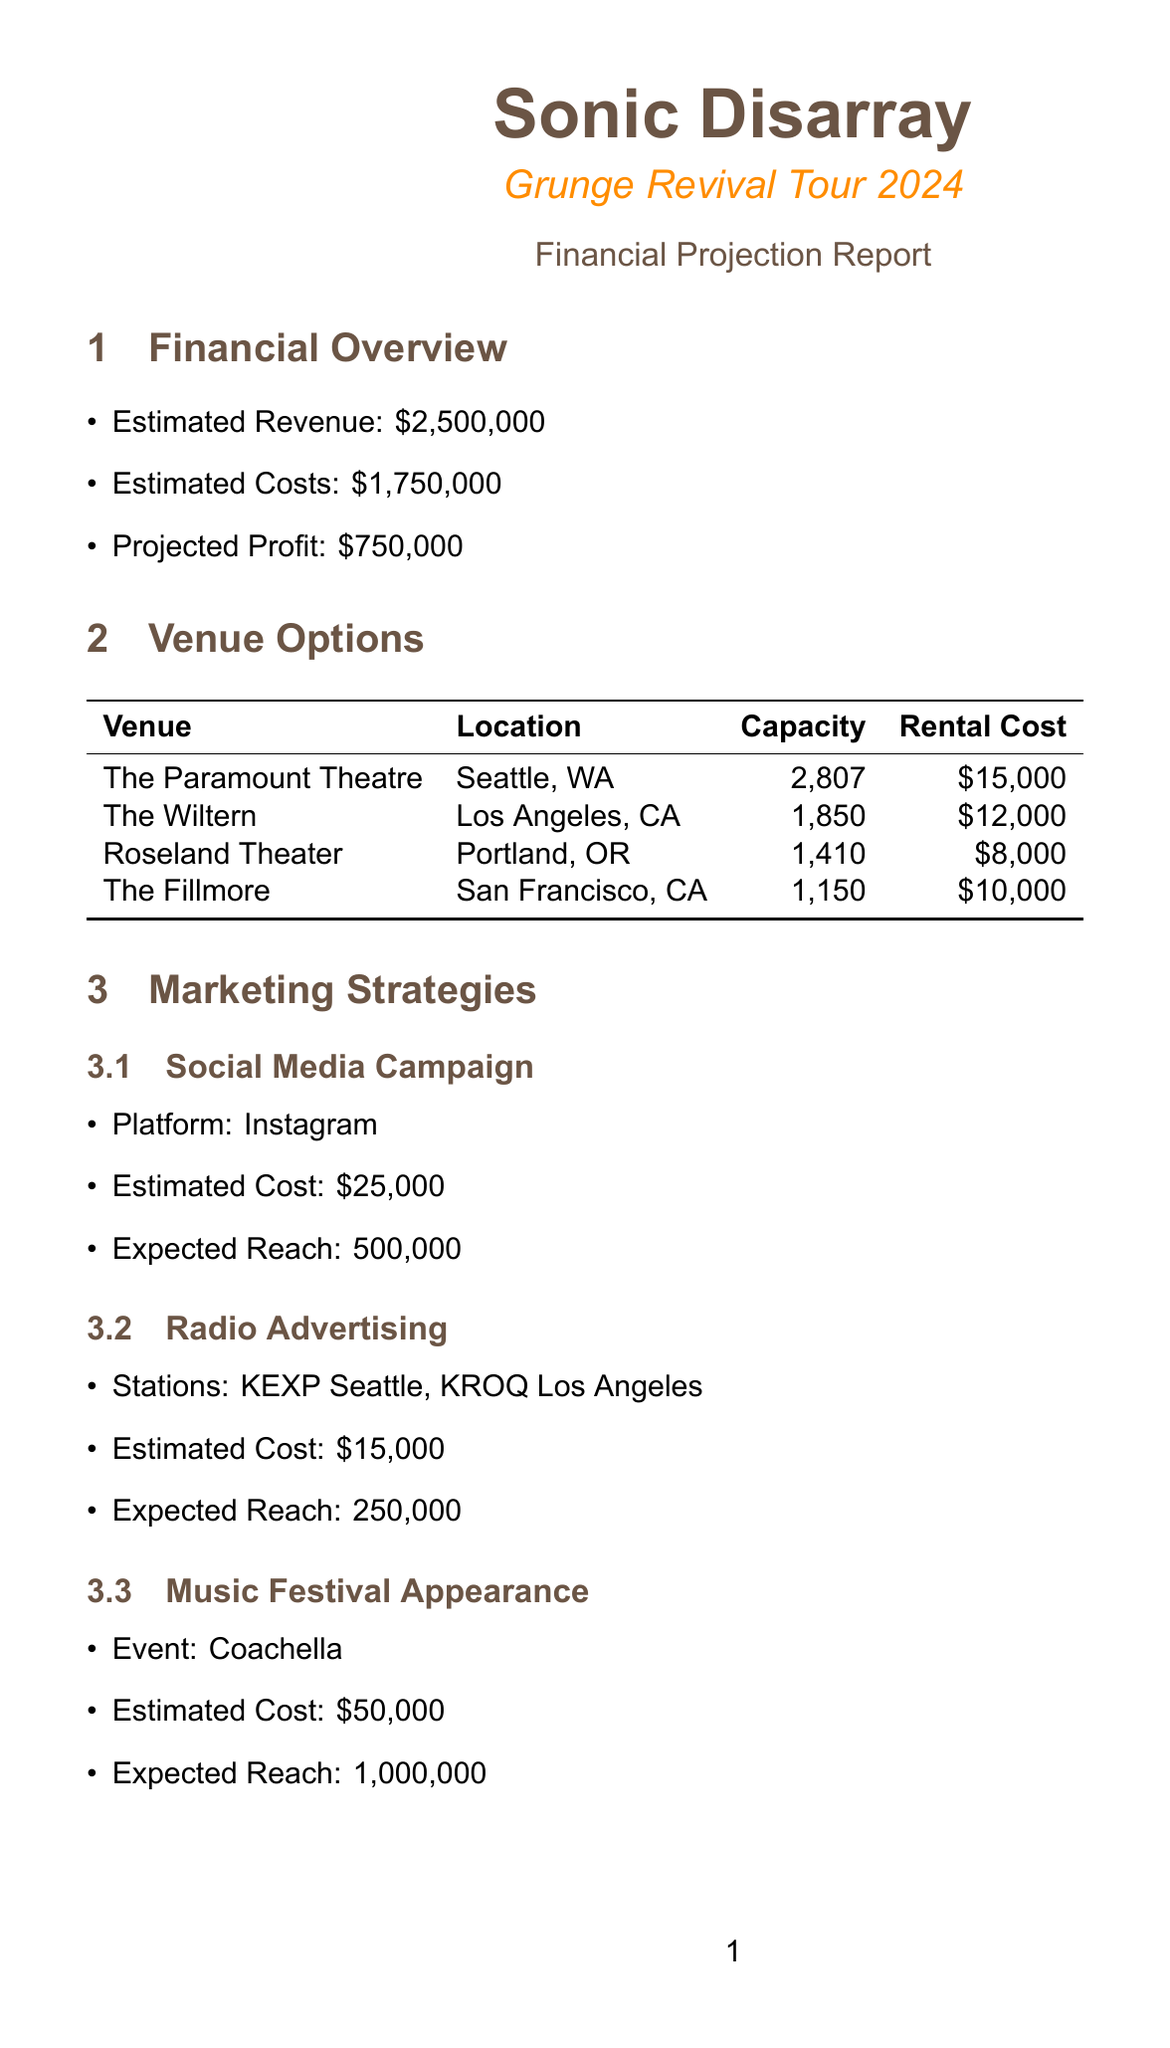what is the estimated revenue for the tour? The estimated revenue is explicitly mentioned in the financial overview section of the document.
Answer: $2,500,000 what is the name of the reunion tour? The name of the reunion tour is stated in the title of the document.
Answer: Grunge Revival Tour 2024 how much is the rental cost for The Fillmore? This rental cost is provided in the venue options table within the document.
Answer: $10,000 what is the expected reach of the Instagram campaign? The expected reach for the Instagram campaign is specified in the marketing strategies section.
Answer: 500,000 how much will be spent on sound equipment? The estimated cost for sound equipment is included in the production costs section.
Answer: $50,000 which venue has the highest capacity? The venue with the highest capacity can be found in the venue options table.
Answer: The Paramount Theatre what is the estimated profit from the reunion tour? The estimated profit is detailed in the financial overview section of the report.
Answer: $750,000 how many roadies will be funded at $150,000? The total salaries for roadies are provided, indicating how much will be allocated for them.
Answer: $150,000 what strategy is expected to reach 1,000,000 people? The expected reach for this strategy is mentioned in the marketing strategies section of the document.
Answer: Music Festival Appearance 